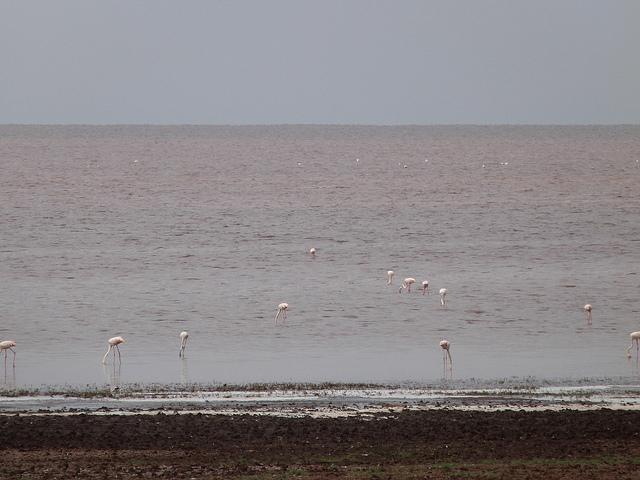What color will these birds become? Please explain your reasoning. bright pink. These birds look like flamingos. and if they are flamingos turn pink at some point due to their diet. 